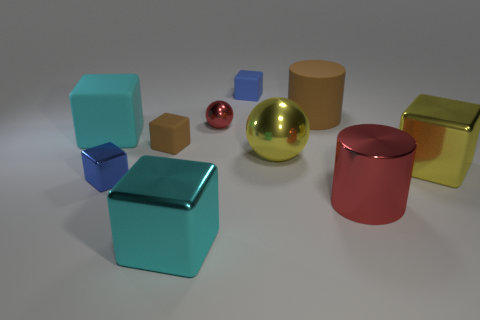What number of yellow things are there?
Ensure brevity in your answer.  2. There is a blue block that is to the left of the blue matte object; does it have the same size as the brown object that is in front of the tiny sphere?
Offer a very short reply. Yes. There is a small metal object that is the same shape as the cyan rubber thing; what is its color?
Offer a terse response. Blue. Does the large red shiny thing have the same shape as the large brown object?
Keep it short and to the point. Yes. There is a cyan metallic object that is the same shape as the blue metallic thing; what size is it?
Keep it short and to the point. Large. How many other spheres are made of the same material as the red ball?
Offer a very short reply. 1. How many objects are either large blue balls or tiny objects?
Keep it short and to the point. 4. There is a tiny matte block that is in front of the small blue matte block; is there a shiny thing that is right of it?
Give a very brief answer. Yes. Are there more tiny metal things that are in front of the big cyan rubber object than cyan matte blocks right of the cyan shiny cube?
Offer a very short reply. Yes. What material is the tiny object that is the same color as the shiny cylinder?
Give a very brief answer. Metal. 